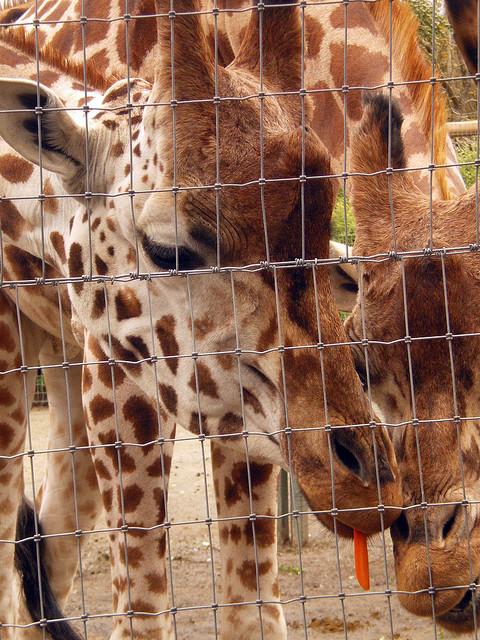What is this giraffe eating?
Keep it brief. Carrot. How many giraffes are in this photo?
Quick response, please. 2. Are the giraffes enclosed?
Keep it brief. Yes. 